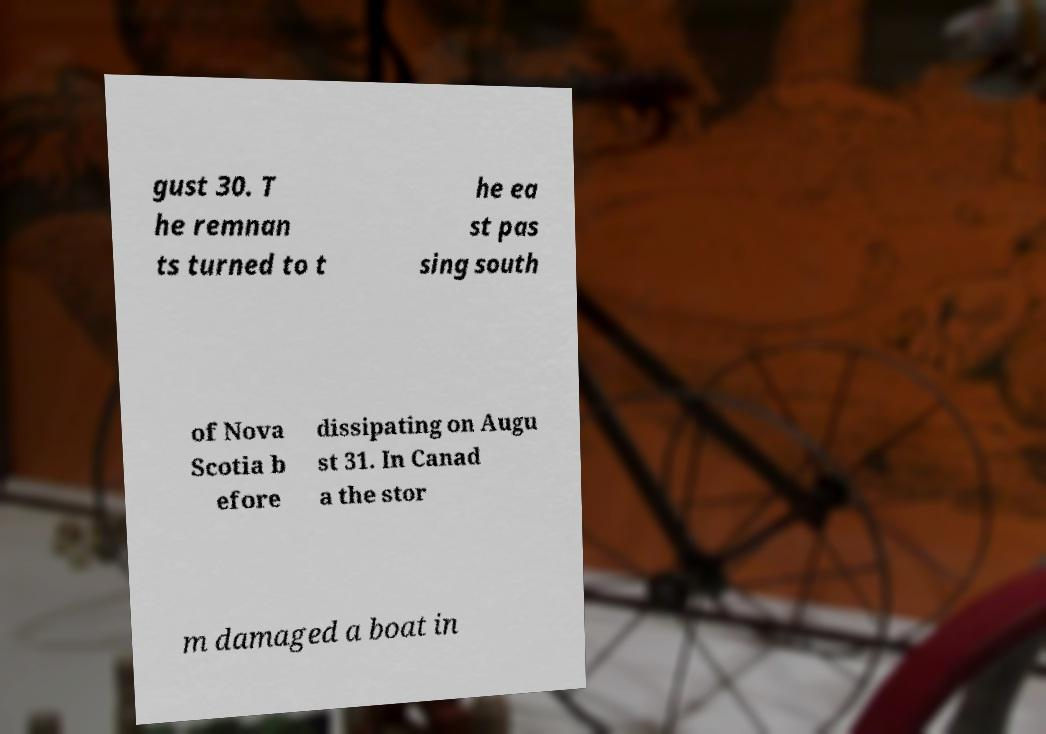Can you read and provide the text displayed in the image?This photo seems to have some interesting text. Can you extract and type it out for me? gust 30. T he remnan ts turned to t he ea st pas sing south of Nova Scotia b efore dissipating on Augu st 31. In Canad a the stor m damaged a boat in 